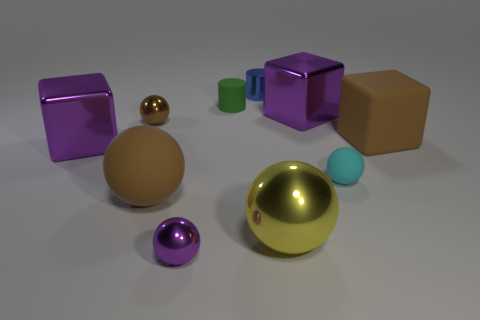Subtract 1 balls. How many balls are left? 4 Subtract all yellow spheres. How many spheres are left? 4 Subtract all purple metal blocks. How many blocks are left? 1 Subtract all blue balls. Subtract all yellow cubes. How many balls are left? 5 Subtract all blocks. How many objects are left? 7 Add 7 purple cubes. How many purple cubes exist? 9 Subtract 0 gray cylinders. How many objects are left? 10 Subtract all yellow cylinders. Subtract all green objects. How many objects are left? 9 Add 1 big yellow shiny balls. How many big yellow shiny balls are left? 2 